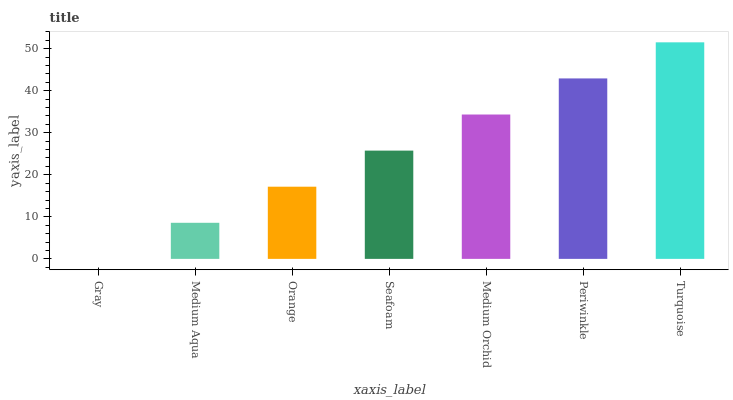Is Gray the minimum?
Answer yes or no. Yes. Is Turquoise the maximum?
Answer yes or no. Yes. Is Medium Aqua the minimum?
Answer yes or no. No. Is Medium Aqua the maximum?
Answer yes or no. No. Is Medium Aqua greater than Gray?
Answer yes or no. Yes. Is Gray less than Medium Aqua?
Answer yes or no. Yes. Is Gray greater than Medium Aqua?
Answer yes or no. No. Is Medium Aqua less than Gray?
Answer yes or no. No. Is Seafoam the high median?
Answer yes or no. Yes. Is Seafoam the low median?
Answer yes or no. Yes. Is Orange the high median?
Answer yes or no. No. Is Medium Aqua the low median?
Answer yes or no. No. 